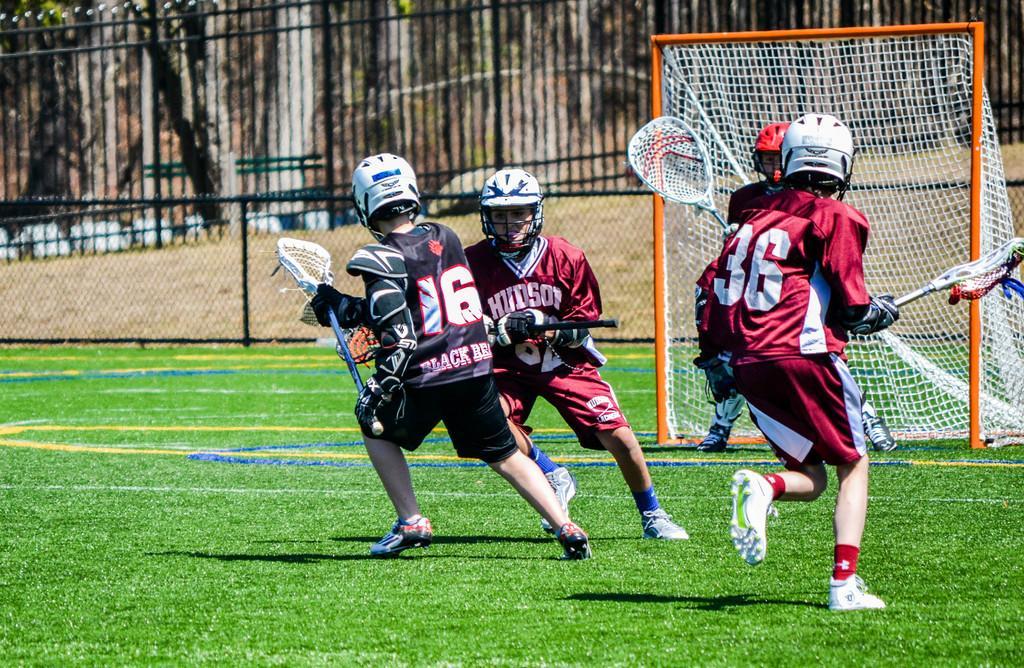Describe this image in one or two sentences. In this image we can see players on the ground and we can also fence and the grass. 